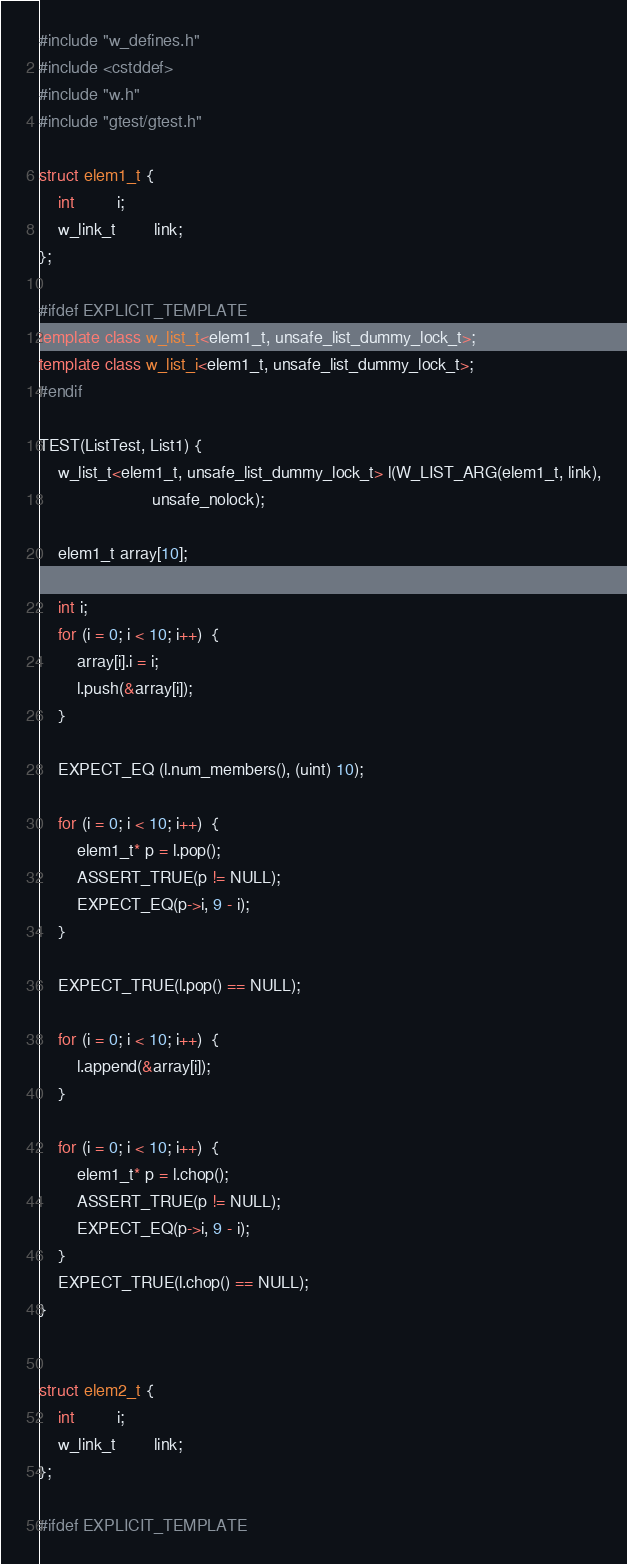Convert code to text. <code><loc_0><loc_0><loc_500><loc_500><_C++_>#include "w_defines.h"
#include <cstddef>
#include "w.h"
#include "gtest/gtest.h"

struct elem1_t {
    int         i;
    w_link_t        link;
};

#ifdef EXPLICIT_TEMPLATE
template class w_list_t<elem1_t, unsafe_list_dummy_lock_t>;
template class w_list_i<elem1_t, unsafe_list_dummy_lock_t>;
#endif

TEST(ListTest, List1) {
    w_list_t<elem1_t, unsafe_list_dummy_lock_t> l(W_LIST_ARG(elem1_t, link),
                        unsafe_nolock);

    elem1_t array[10];

    int i;
    for (i = 0; i < 10; i++)  {
        array[i].i = i;
        l.push(&array[i]);
    }

    EXPECT_EQ (l.num_members(), (uint) 10);

    for (i = 0; i < 10; i++)  {
        elem1_t* p = l.pop();
        ASSERT_TRUE(p != NULL);
        EXPECT_EQ(p->i, 9 - i);
    }

    EXPECT_TRUE(l.pop() == NULL);

    for (i = 0; i < 10; i++)  {
        l.append(&array[i]);
    }

    for (i = 0; i < 10; i++)  {
        elem1_t* p = l.chop();
        ASSERT_TRUE(p != NULL);
        EXPECT_EQ(p->i, 9 - i);
    }
    EXPECT_TRUE(l.chop() == NULL);
}


struct elem2_t {
    int         i;
    w_link_t        link;
};

#ifdef EXPLICIT_TEMPLATE</code> 